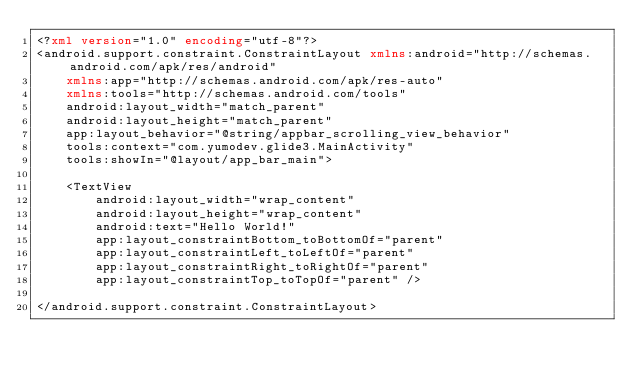Convert code to text. <code><loc_0><loc_0><loc_500><loc_500><_XML_><?xml version="1.0" encoding="utf-8"?>
<android.support.constraint.ConstraintLayout xmlns:android="http://schemas.android.com/apk/res/android"
    xmlns:app="http://schemas.android.com/apk/res-auto"
    xmlns:tools="http://schemas.android.com/tools"
    android:layout_width="match_parent"
    android:layout_height="match_parent"
    app:layout_behavior="@string/appbar_scrolling_view_behavior"
    tools:context="com.yumodev.glide3.MainActivity"
    tools:showIn="@layout/app_bar_main">

    <TextView
        android:layout_width="wrap_content"
        android:layout_height="wrap_content"
        android:text="Hello World!"
        app:layout_constraintBottom_toBottomOf="parent"
        app:layout_constraintLeft_toLeftOf="parent"
        app:layout_constraintRight_toRightOf="parent"
        app:layout_constraintTop_toTopOf="parent" />

</android.support.constraint.ConstraintLayout>
</code> 